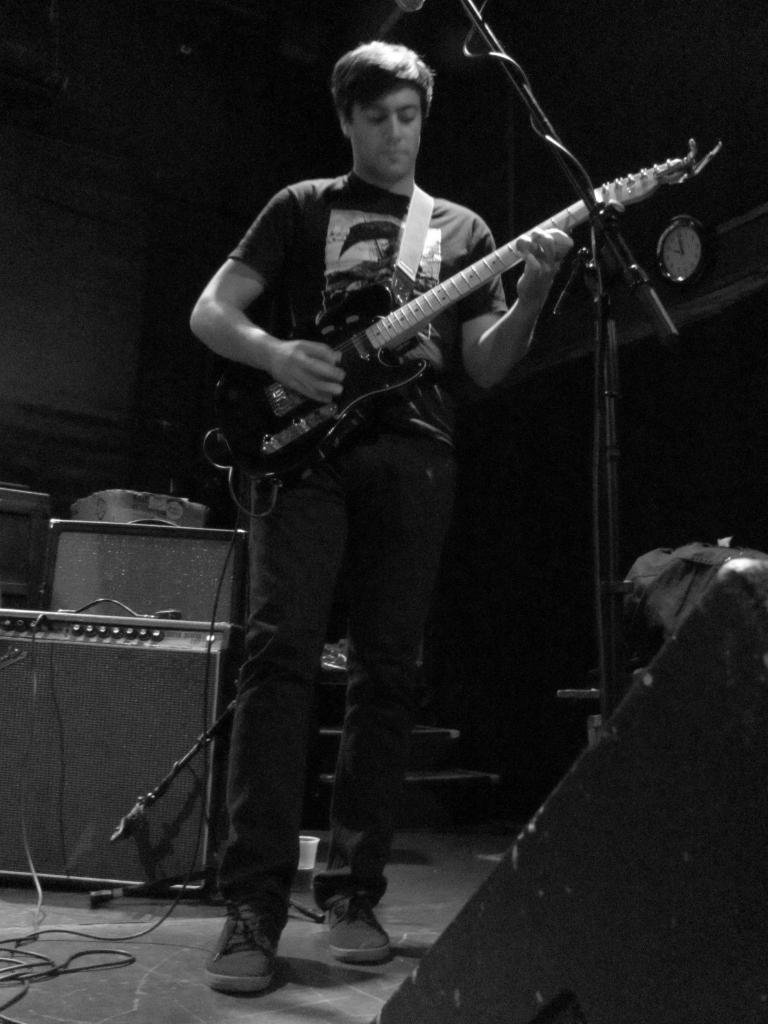What is the person in the image doing? The person in the image is playing a guitar. What object is in front of the person? There is a microphone in front of the person. Can you tell me how many birds are flying around the person in the image? There are no birds visible in the image. What type of sense is the person using to play the guitar in the image? The person is using their sense of touch and possibly their sense of hearing to play the guitar, but the image does not provide information about other senses. 